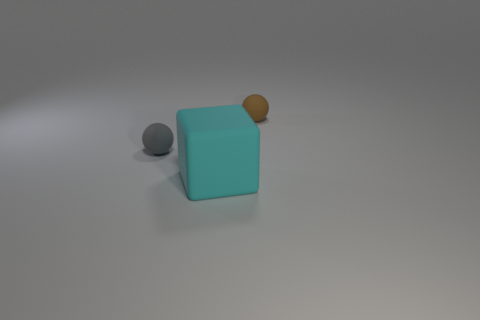There is a small rubber ball on the right side of the gray thing; how many gray balls are behind it?
Your response must be concise. 0. There is a gray rubber object; does it have the same size as the matte block that is in front of the brown ball?
Provide a short and direct response. No. Do the cyan cube and the gray ball have the same size?
Make the answer very short. No. Are there any objects of the same size as the gray ball?
Offer a terse response. Yes. What is the material of the ball that is to the left of the big matte block?
Make the answer very short. Rubber. The big object that is made of the same material as the tiny gray sphere is what color?
Give a very brief answer. Cyan. What number of rubber things are either tiny objects or cyan things?
Provide a succinct answer. 3. What shape is the other matte object that is the same size as the brown thing?
Make the answer very short. Sphere. What number of things are either matte objects that are right of the small gray sphere or brown matte things behind the large rubber cube?
Provide a succinct answer. 2. What material is the gray thing that is the same size as the brown sphere?
Ensure brevity in your answer.  Rubber. 